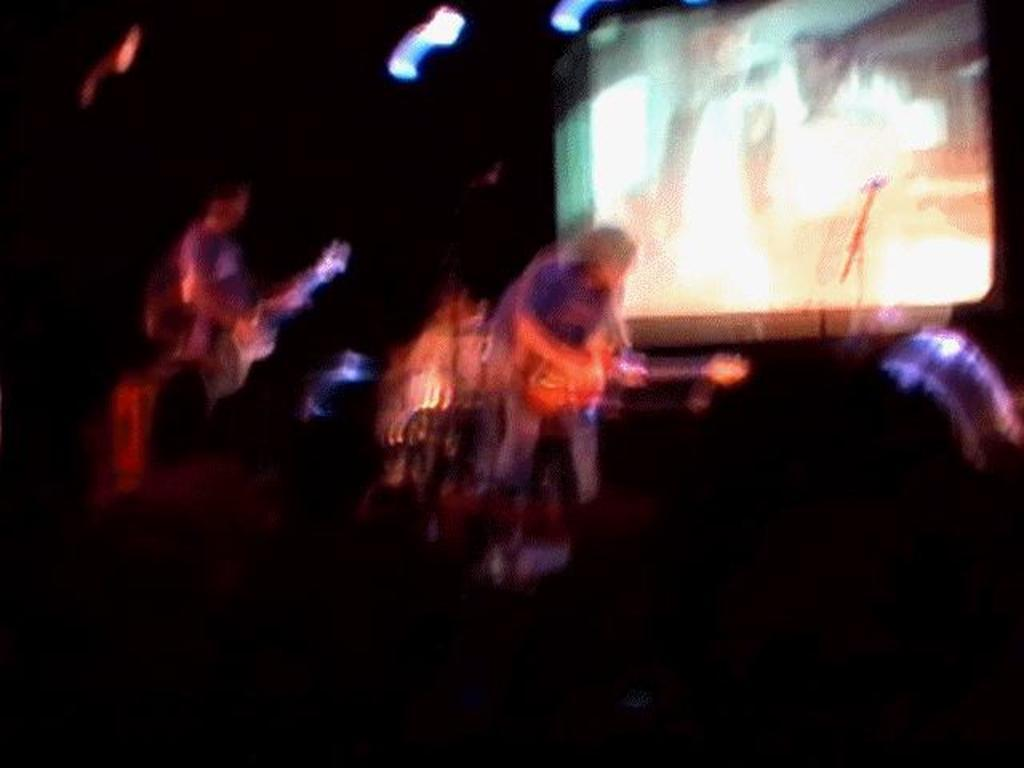What is happening in the image? There is a band performing in the image. What instruments are being played by the band members? People are playing guitars in the image. Can you describe the background of the image? There is a screen in the background of the image, but its appearance cannot be accurately described due to the blurriness of the image. What type of milk is being served to the band members during their performance? There is no milk present in the image, as it features a band performing with guitars and a blurred background. 